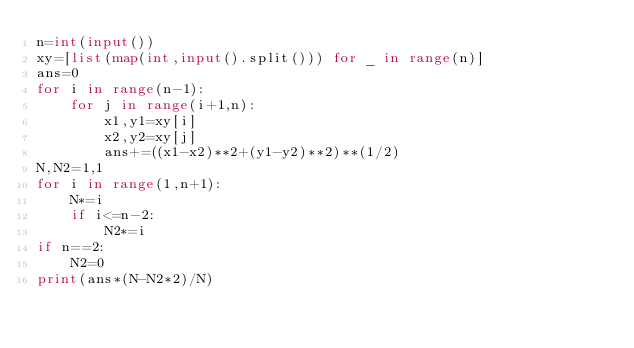<code> <loc_0><loc_0><loc_500><loc_500><_Python_>n=int(input())
xy=[list(map(int,input().split())) for _ in range(n)]
ans=0
for i in range(n-1):
    for j in range(i+1,n):
        x1,y1=xy[i]
        x2,y2=xy[j]
        ans+=((x1-x2)**2+(y1-y2)**2)**(1/2)
N,N2=1,1
for i in range(1,n+1):
    N*=i
    if i<=n-2:
        N2*=i
if n==2:
    N2=0
print(ans*(N-N2*2)/N)</code> 